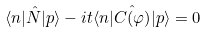<formula> <loc_0><loc_0><loc_500><loc_500>\langle n | \hat { N } | p \rangle - i t \langle n | \hat { C ( \varphi ) } | p \rangle = 0</formula> 